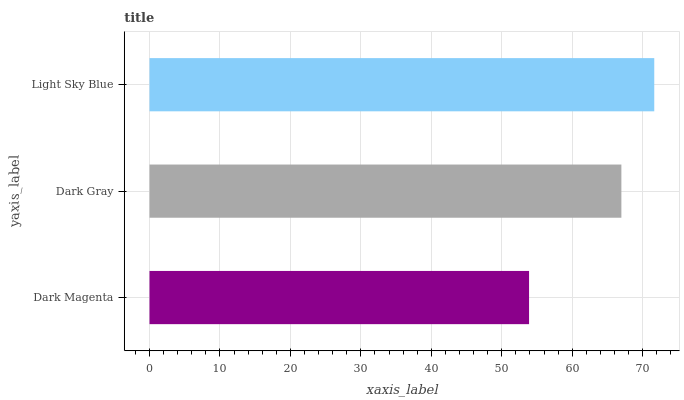Is Dark Magenta the minimum?
Answer yes or no. Yes. Is Light Sky Blue the maximum?
Answer yes or no. Yes. Is Dark Gray the minimum?
Answer yes or no. No. Is Dark Gray the maximum?
Answer yes or no. No. Is Dark Gray greater than Dark Magenta?
Answer yes or no. Yes. Is Dark Magenta less than Dark Gray?
Answer yes or no. Yes. Is Dark Magenta greater than Dark Gray?
Answer yes or no. No. Is Dark Gray less than Dark Magenta?
Answer yes or no. No. Is Dark Gray the high median?
Answer yes or no. Yes. Is Dark Gray the low median?
Answer yes or no. Yes. Is Light Sky Blue the high median?
Answer yes or no. No. Is Dark Magenta the low median?
Answer yes or no. No. 